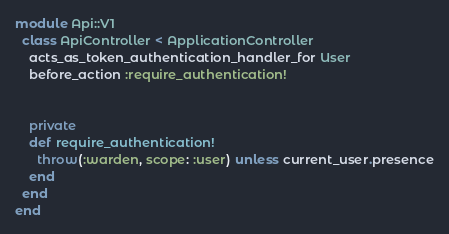<code> <loc_0><loc_0><loc_500><loc_500><_Ruby_>module Api::V1
  class ApiController < ApplicationController
    acts_as_token_authentication_handler_for User
    before_action :require_authentication!


    private
    def require_authentication!
      throw(:warden, scope: :user) unless current_user.presence
    end
  end
end</code> 